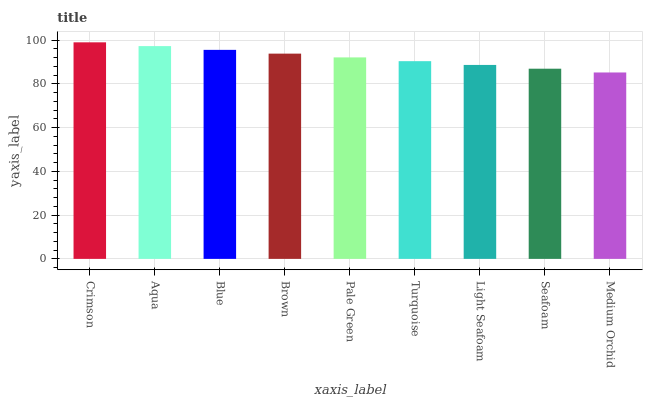Is Medium Orchid the minimum?
Answer yes or no. Yes. Is Crimson the maximum?
Answer yes or no. Yes. Is Aqua the minimum?
Answer yes or no. No. Is Aqua the maximum?
Answer yes or no. No. Is Crimson greater than Aqua?
Answer yes or no. Yes. Is Aqua less than Crimson?
Answer yes or no. Yes. Is Aqua greater than Crimson?
Answer yes or no. No. Is Crimson less than Aqua?
Answer yes or no. No. Is Pale Green the high median?
Answer yes or no. Yes. Is Pale Green the low median?
Answer yes or no. Yes. Is Brown the high median?
Answer yes or no. No. Is Light Seafoam the low median?
Answer yes or no. No. 